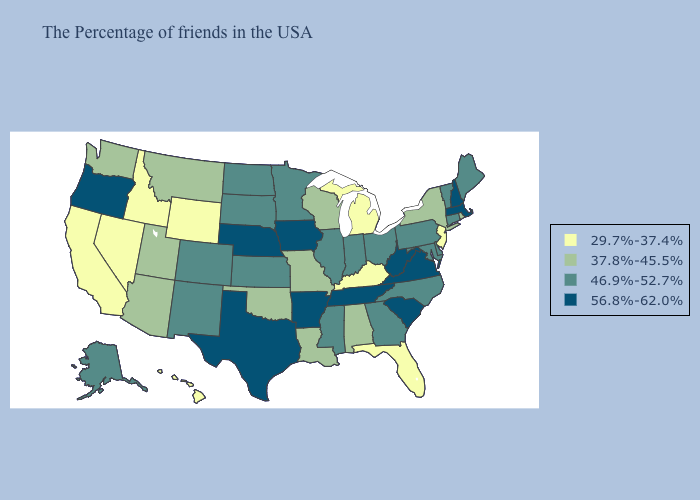What is the value of Georgia?
Quick response, please. 46.9%-52.7%. Among the states that border Virginia , does Kentucky have the lowest value?
Short answer required. Yes. Name the states that have a value in the range 56.8%-62.0%?
Be succinct. Massachusetts, New Hampshire, Virginia, South Carolina, West Virginia, Tennessee, Arkansas, Iowa, Nebraska, Texas, Oregon. Does Washington have the highest value in the USA?
Quick response, please. No. Is the legend a continuous bar?
Quick response, please. No. Name the states that have a value in the range 29.7%-37.4%?
Be succinct. New Jersey, Florida, Michigan, Kentucky, Wyoming, Idaho, Nevada, California, Hawaii. Does New Hampshire have the highest value in the Northeast?
Short answer required. Yes. What is the lowest value in the Northeast?
Write a very short answer. 29.7%-37.4%. What is the lowest value in the USA?
Write a very short answer. 29.7%-37.4%. What is the value of Colorado?
Give a very brief answer. 46.9%-52.7%. Name the states that have a value in the range 29.7%-37.4%?
Answer briefly. New Jersey, Florida, Michigan, Kentucky, Wyoming, Idaho, Nevada, California, Hawaii. Name the states that have a value in the range 29.7%-37.4%?
Write a very short answer. New Jersey, Florida, Michigan, Kentucky, Wyoming, Idaho, Nevada, California, Hawaii. Among the states that border Missouri , which have the highest value?
Short answer required. Tennessee, Arkansas, Iowa, Nebraska. Which states have the lowest value in the USA?
Write a very short answer. New Jersey, Florida, Michigan, Kentucky, Wyoming, Idaho, Nevada, California, Hawaii. Which states have the highest value in the USA?
Be succinct. Massachusetts, New Hampshire, Virginia, South Carolina, West Virginia, Tennessee, Arkansas, Iowa, Nebraska, Texas, Oregon. 